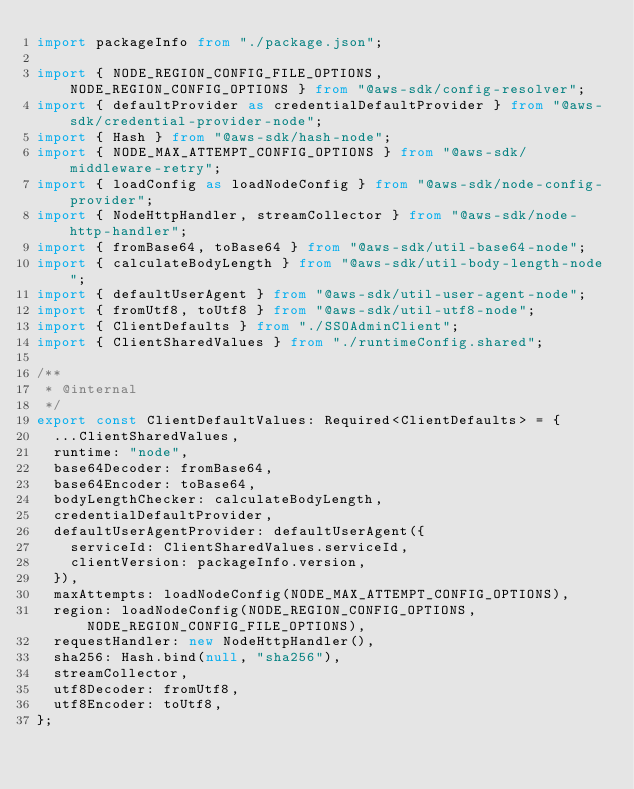Convert code to text. <code><loc_0><loc_0><loc_500><loc_500><_TypeScript_>import packageInfo from "./package.json";

import { NODE_REGION_CONFIG_FILE_OPTIONS, NODE_REGION_CONFIG_OPTIONS } from "@aws-sdk/config-resolver";
import { defaultProvider as credentialDefaultProvider } from "@aws-sdk/credential-provider-node";
import { Hash } from "@aws-sdk/hash-node";
import { NODE_MAX_ATTEMPT_CONFIG_OPTIONS } from "@aws-sdk/middleware-retry";
import { loadConfig as loadNodeConfig } from "@aws-sdk/node-config-provider";
import { NodeHttpHandler, streamCollector } from "@aws-sdk/node-http-handler";
import { fromBase64, toBase64 } from "@aws-sdk/util-base64-node";
import { calculateBodyLength } from "@aws-sdk/util-body-length-node";
import { defaultUserAgent } from "@aws-sdk/util-user-agent-node";
import { fromUtf8, toUtf8 } from "@aws-sdk/util-utf8-node";
import { ClientDefaults } from "./SSOAdminClient";
import { ClientSharedValues } from "./runtimeConfig.shared";

/**
 * @internal
 */
export const ClientDefaultValues: Required<ClientDefaults> = {
  ...ClientSharedValues,
  runtime: "node",
  base64Decoder: fromBase64,
  base64Encoder: toBase64,
  bodyLengthChecker: calculateBodyLength,
  credentialDefaultProvider,
  defaultUserAgentProvider: defaultUserAgent({
    serviceId: ClientSharedValues.serviceId,
    clientVersion: packageInfo.version,
  }),
  maxAttempts: loadNodeConfig(NODE_MAX_ATTEMPT_CONFIG_OPTIONS),
  region: loadNodeConfig(NODE_REGION_CONFIG_OPTIONS, NODE_REGION_CONFIG_FILE_OPTIONS),
  requestHandler: new NodeHttpHandler(),
  sha256: Hash.bind(null, "sha256"),
  streamCollector,
  utf8Decoder: fromUtf8,
  utf8Encoder: toUtf8,
};
</code> 